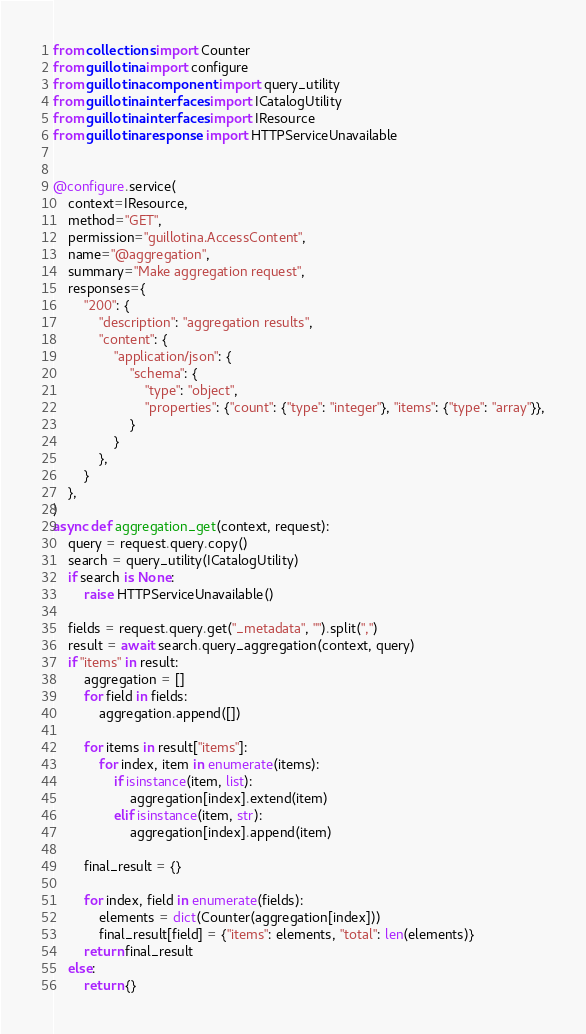<code> <loc_0><loc_0><loc_500><loc_500><_Python_>from collections import Counter
from guillotina import configure
from guillotina.component import query_utility
from guillotina.interfaces import ICatalogUtility
from guillotina.interfaces import IResource
from guillotina.response import HTTPServiceUnavailable


@configure.service(
    context=IResource,
    method="GET",
    permission="guillotina.AccessContent",
    name="@aggregation",
    summary="Make aggregation request",
    responses={
        "200": {
            "description": "aggregation results",
            "content": {
                "application/json": {
                    "schema": {
                        "type": "object",
                        "properties": {"count": {"type": "integer"}, "items": {"type": "array"}},
                    }
                }
            },
        }
    },
)
async def aggregation_get(context, request):
    query = request.query.copy()
    search = query_utility(ICatalogUtility)
    if search is None:
        raise HTTPServiceUnavailable()

    fields = request.query.get("_metadata", "").split(",")
    result = await search.query_aggregation(context, query)
    if "items" in result:
        aggregation = []
        for field in fields:
            aggregation.append([])

        for items in result["items"]:
            for index, item in enumerate(items):
                if isinstance(item, list):
                    aggregation[index].extend(item)
                elif isinstance(item, str):
                    aggregation[index].append(item)

        final_result = {}

        for index, field in enumerate(fields):
            elements = dict(Counter(aggregation[index]))
            final_result[field] = {"items": elements, "total": len(elements)}
        return final_result
    else:
        return {}
</code> 